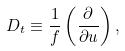<formula> <loc_0><loc_0><loc_500><loc_500>D _ { t } \equiv \frac { 1 } { f } \left ( \frac { \partial } { \partial u } \right ) ,</formula> 